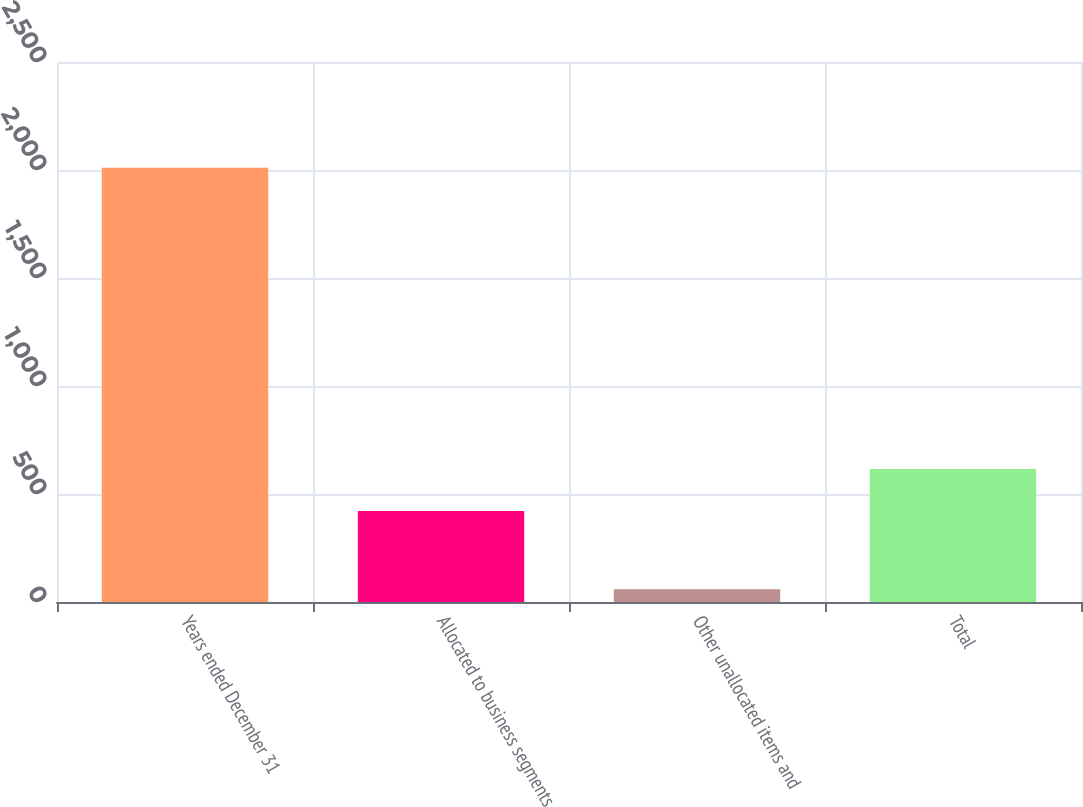Convert chart to OTSL. <chart><loc_0><loc_0><loc_500><loc_500><bar_chart><fcel>Years ended December 31<fcel>Allocated to business segments<fcel>Other unallocated items and<fcel>Total<nl><fcel>2010<fcel>421<fcel>59<fcel>616.1<nl></chart> 